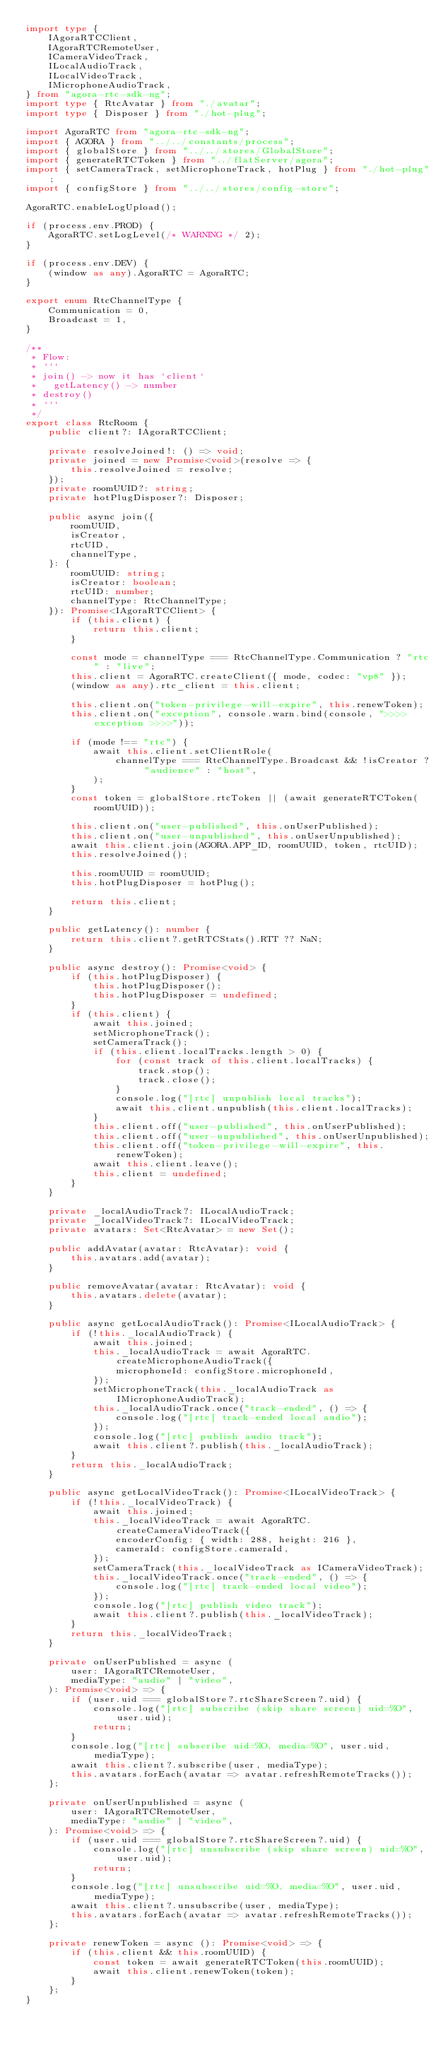<code> <loc_0><loc_0><loc_500><loc_500><_TypeScript_>import type {
    IAgoraRTCClient,
    IAgoraRTCRemoteUser,
    ICameraVideoTrack,
    ILocalAudioTrack,
    ILocalVideoTrack,
    IMicrophoneAudioTrack,
} from "agora-rtc-sdk-ng";
import type { RtcAvatar } from "./avatar";
import type { Disposer } from "./hot-plug";

import AgoraRTC from "agora-rtc-sdk-ng";
import { AGORA } from "../../constants/process";
import { globalStore } from "../../stores/GlobalStore";
import { generateRTCToken } from "../flatServer/agora";
import { setCameraTrack, setMicrophoneTrack, hotPlug } from "./hot-plug";
import { configStore } from "../../stores/config-store";

AgoraRTC.enableLogUpload();

if (process.env.PROD) {
    AgoraRTC.setLogLevel(/* WARNING */ 2);
}

if (process.env.DEV) {
    (window as any).AgoraRTC = AgoraRTC;
}

export enum RtcChannelType {
    Communication = 0,
    Broadcast = 1,
}

/**
 * Flow:
 * ```
 * join() -> now it has `client`
 *   getLatency() -> number
 * destroy()
 * ```
 */
export class RtcRoom {
    public client?: IAgoraRTCClient;

    private resolveJoined!: () => void;
    private joined = new Promise<void>(resolve => {
        this.resolveJoined = resolve;
    });
    private roomUUID?: string;
    private hotPlugDisposer?: Disposer;

    public async join({
        roomUUID,
        isCreator,
        rtcUID,
        channelType,
    }: {
        roomUUID: string;
        isCreator: boolean;
        rtcUID: number;
        channelType: RtcChannelType;
    }): Promise<IAgoraRTCClient> {
        if (this.client) {
            return this.client;
        }

        const mode = channelType === RtcChannelType.Communication ? "rtc" : "live";
        this.client = AgoraRTC.createClient({ mode, codec: "vp8" });
        (window as any).rtc_client = this.client;

        this.client.on("token-privilege-will-expire", this.renewToken);
        this.client.on("exception", console.warn.bind(console, ">>>> exception >>>>"));

        if (mode !== "rtc") {
            await this.client.setClientRole(
                channelType === RtcChannelType.Broadcast && !isCreator ? "audience" : "host",
            );
        }
        const token = globalStore.rtcToken || (await generateRTCToken(roomUUID));

        this.client.on("user-published", this.onUserPublished);
        this.client.on("user-unpublished", this.onUserUnpublished);
        await this.client.join(AGORA.APP_ID, roomUUID, token, rtcUID);
        this.resolveJoined();

        this.roomUUID = roomUUID;
        this.hotPlugDisposer = hotPlug();

        return this.client;
    }

    public getLatency(): number {
        return this.client?.getRTCStats().RTT ?? NaN;
    }

    public async destroy(): Promise<void> {
        if (this.hotPlugDisposer) {
            this.hotPlugDisposer();
            this.hotPlugDisposer = undefined;
        }
        if (this.client) {
            await this.joined;
            setMicrophoneTrack();
            setCameraTrack();
            if (this.client.localTracks.length > 0) {
                for (const track of this.client.localTracks) {
                    track.stop();
                    track.close();
                }
                console.log("[rtc] unpublish local tracks");
                await this.client.unpublish(this.client.localTracks);
            }
            this.client.off("user-published", this.onUserPublished);
            this.client.off("user-unpublished", this.onUserUnpublished);
            this.client.off("token-privilege-will-expire", this.renewToken);
            await this.client.leave();
            this.client = undefined;
        }
    }

    private _localAudioTrack?: ILocalAudioTrack;
    private _localVideoTrack?: ILocalVideoTrack;
    private avatars: Set<RtcAvatar> = new Set();

    public addAvatar(avatar: RtcAvatar): void {
        this.avatars.add(avatar);
    }

    public removeAvatar(avatar: RtcAvatar): void {
        this.avatars.delete(avatar);
    }

    public async getLocalAudioTrack(): Promise<ILocalAudioTrack> {
        if (!this._localAudioTrack) {
            await this.joined;
            this._localAudioTrack = await AgoraRTC.createMicrophoneAudioTrack({
                microphoneId: configStore.microphoneId,
            });
            setMicrophoneTrack(this._localAudioTrack as IMicrophoneAudioTrack);
            this._localAudioTrack.once("track-ended", () => {
                console.log("[rtc] track-ended local audio");
            });
            console.log("[rtc] publish audio track");
            await this.client?.publish(this._localAudioTrack);
        }
        return this._localAudioTrack;
    }

    public async getLocalVideoTrack(): Promise<ILocalVideoTrack> {
        if (!this._localVideoTrack) {
            await this.joined;
            this._localVideoTrack = await AgoraRTC.createCameraVideoTrack({
                encoderConfig: { width: 288, height: 216 },
                cameraId: configStore.cameraId,
            });
            setCameraTrack(this._localVideoTrack as ICameraVideoTrack);
            this._localVideoTrack.once("track-ended", () => {
                console.log("[rtc] track-ended local video");
            });
            console.log("[rtc] publish video track");
            await this.client?.publish(this._localVideoTrack);
        }
        return this._localVideoTrack;
    }

    private onUserPublished = async (
        user: IAgoraRTCRemoteUser,
        mediaType: "audio" | "video",
    ): Promise<void> => {
        if (user.uid === globalStore?.rtcShareScreen?.uid) {
            console.log("[rtc] subscribe (skip share screen) uid=%O", user.uid);
            return;
        }
        console.log("[rtc] subscribe uid=%O, media=%O", user.uid, mediaType);
        await this.client?.subscribe(user, mediaType);
        this.avatars.forEach(avatar => avatar.refreshRemoteTracks());
    };

    private onUserUnpublished = async (
        user: IAgoraRTCRemoteUser,
        mediaType: "audio" | "video",
    ): Promise<void> => {
        if (user.uid === globalStore?.rtcShareScreen?.uid) {
            console.log("[rtc] unsubscribe (skip share screen) uid=%O", user.uid);
            return;
        }
        console.log("[rtc] unsubscribe uid=%O, media=%O", user.uid, mediaType);
        await this.client?.unsubscribe(user, mediaType);
        this.avatars.forEach(avatar => avatar.refreshRemoteTracks());
    };

    private renewToken = async (): Promise<void> => {
        if (this.client && this.roomUUID) {
            const token = await generateRTCToken(this.roomUUID);
            await this.client.renewToken(token);
        }
    };
}
</code> 